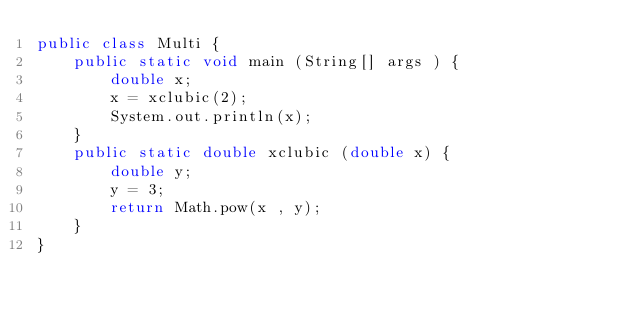Convert code to text. <code><loc_0><loc_0><loc_500><loc_500><_Java_>public class Multi {
    public static void main (String[] args ) {
        double x;
        x = xclubic(2);
        System.out.println(x);
    }
    public static double xclubic (double x) {
        double y;
        y = 3;
        return Math.pow(x , y);
    }
}</code> 